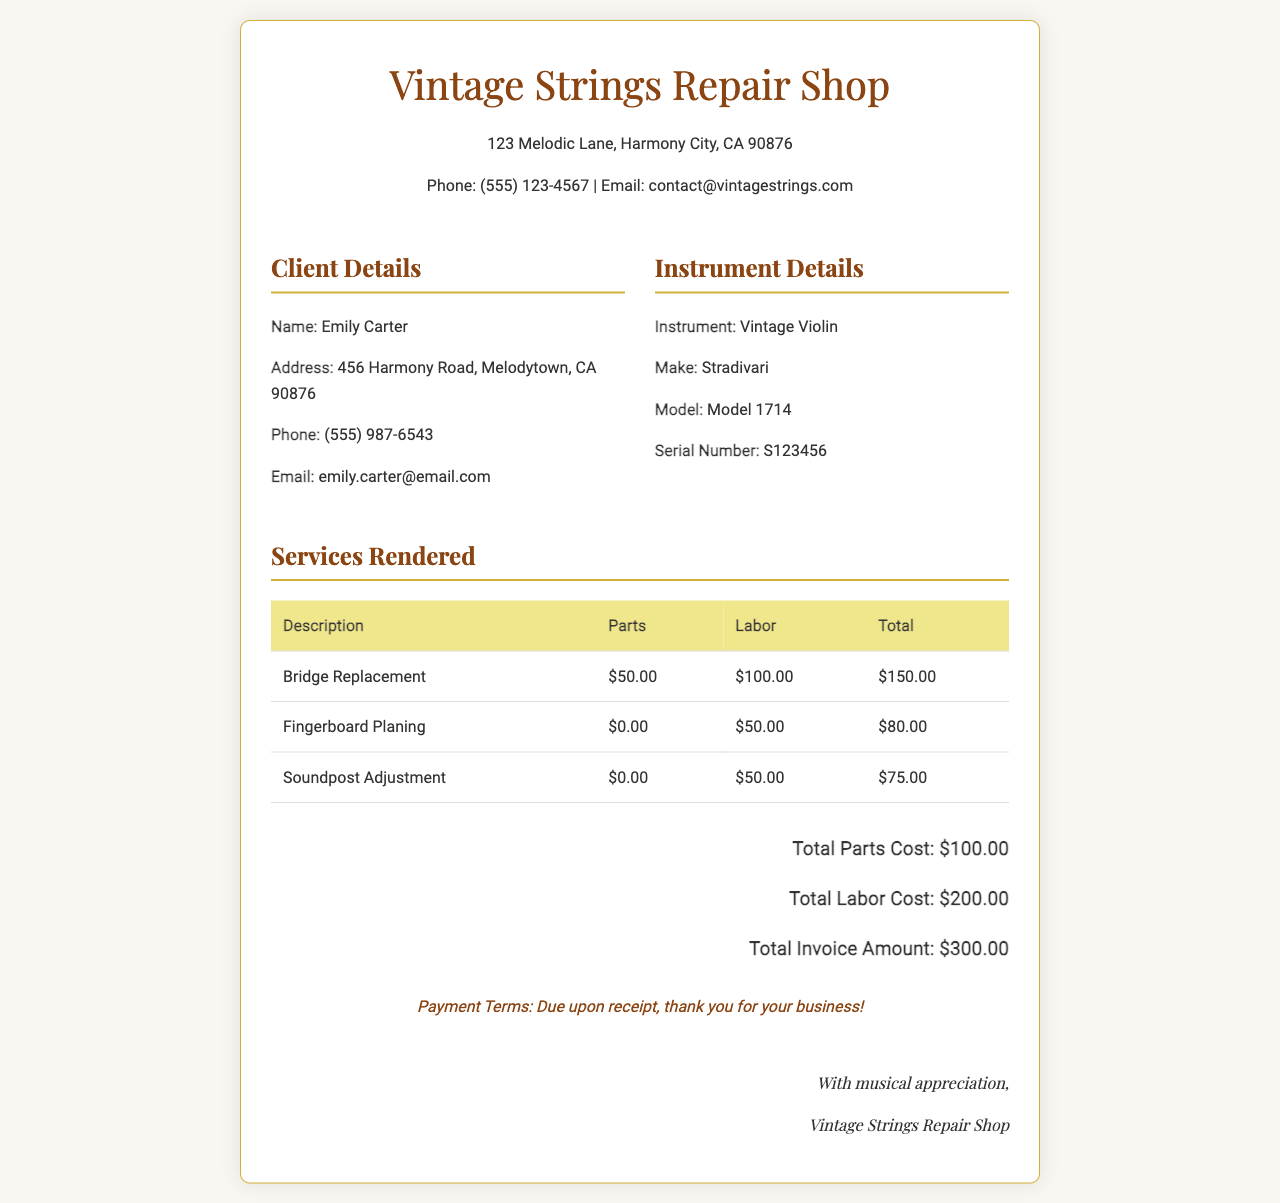What is the client's name? The client's name is specified in the "Client Details" section.
Answer: Emily Carter What is the total invoice amount? The total invoice amount is stated in the total section of the document.
Answer: $300.00 Which instrument is being repaired? The instrument details identify the specific instrument in need of repair.
Answer: Vintage Violin What is the labor cost for Bridge Replacement? The labor cost is detailed in the services rendered table for each service.
Answer: $100.00 What is the model year of the violin? The model year is indicated in the "Instrument Details" section.
Answer: 1714 How much is charged for parts in total? The total parts cost is provided in the summary of costs at the bottom of the invoice.
Answer: $100.00 What is the total cost for Fingerboard Planing? The total cost is the sum of parts and labor for that service from the services rendered table.
Answer: $80.00 What are the payment terms listed? The payment terms are stated in a specific section towards the end of the invoice.
Answer: Due upon receipt How many services were rendered? The number of services is determined by counting the rows in the services rendered table.
Answer: 3 